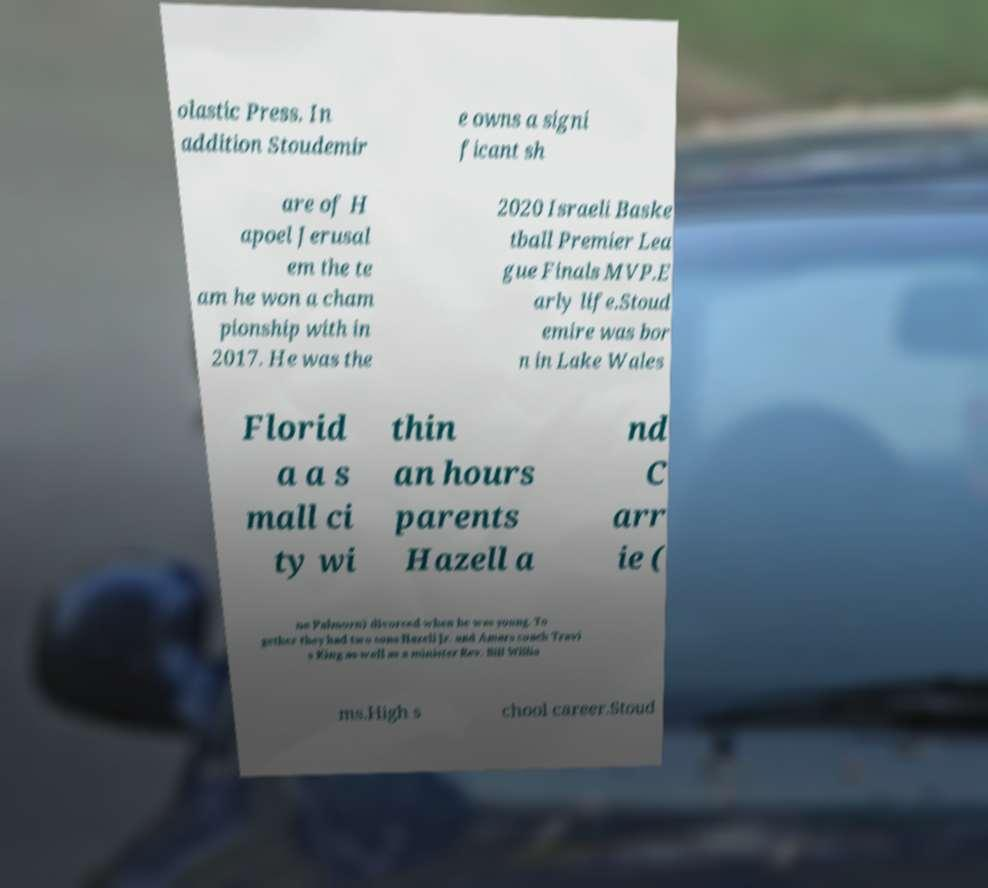For documentation purposes, I need the text within this image transcribed. Could you provide that? olastic Press. In addition Stoudemir e owns a signi ficant sh are of H apoel Jerusal em the te am he won a cham pionship with in 2017. He was the 2020 Israeli Baske tball Premier Lea gue Finals MVP.E arly life.Stoud emire was bor n in Lake Wales Florid a a s mall ci ty wi thin an hours parents Hazell a nd C arr ie ( ne Palmorn) divorced when he was young. To gether they had two sons Hazell Jr. and Amars coach Travi s King as well as a minister Rev. Bill Willia ms.High s chool career.Stoud 